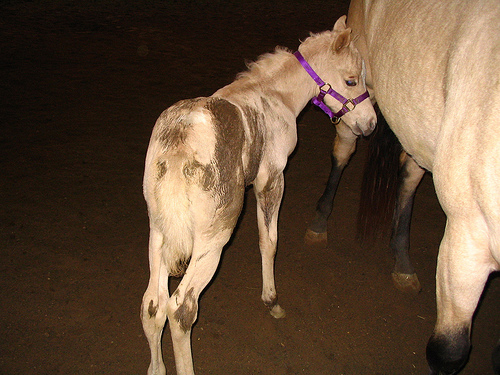<image>
Is there a halter in front of the hoof? No. The halter is not in front of the hoof. The spatial positioning shows a different relationship between these objects. 